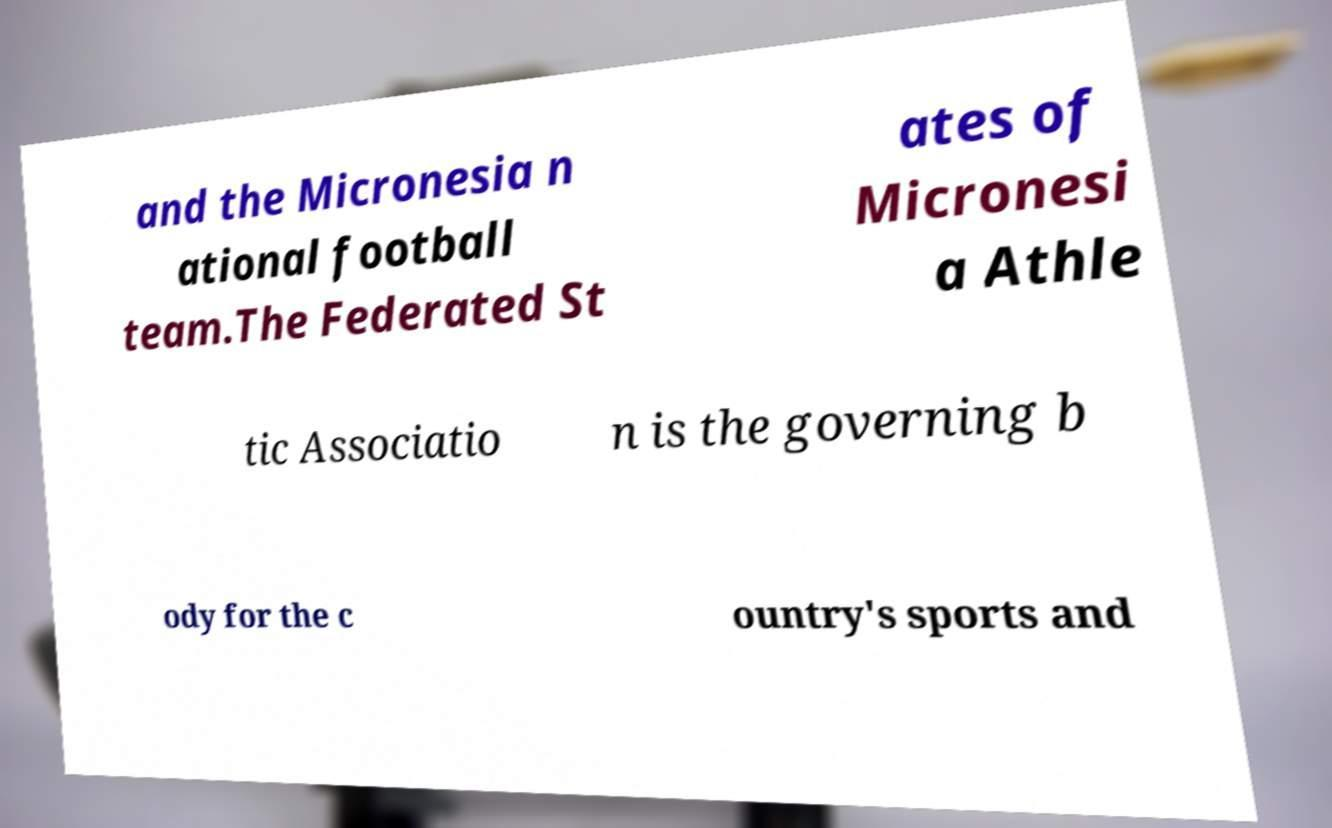Can you accurately transcribe the text from the provided image for me? and the Micronesia n ational football team.The Federated St ates of Micronesi a Athle tic Associatio n is the governing b ody for the c ountry's sports and 